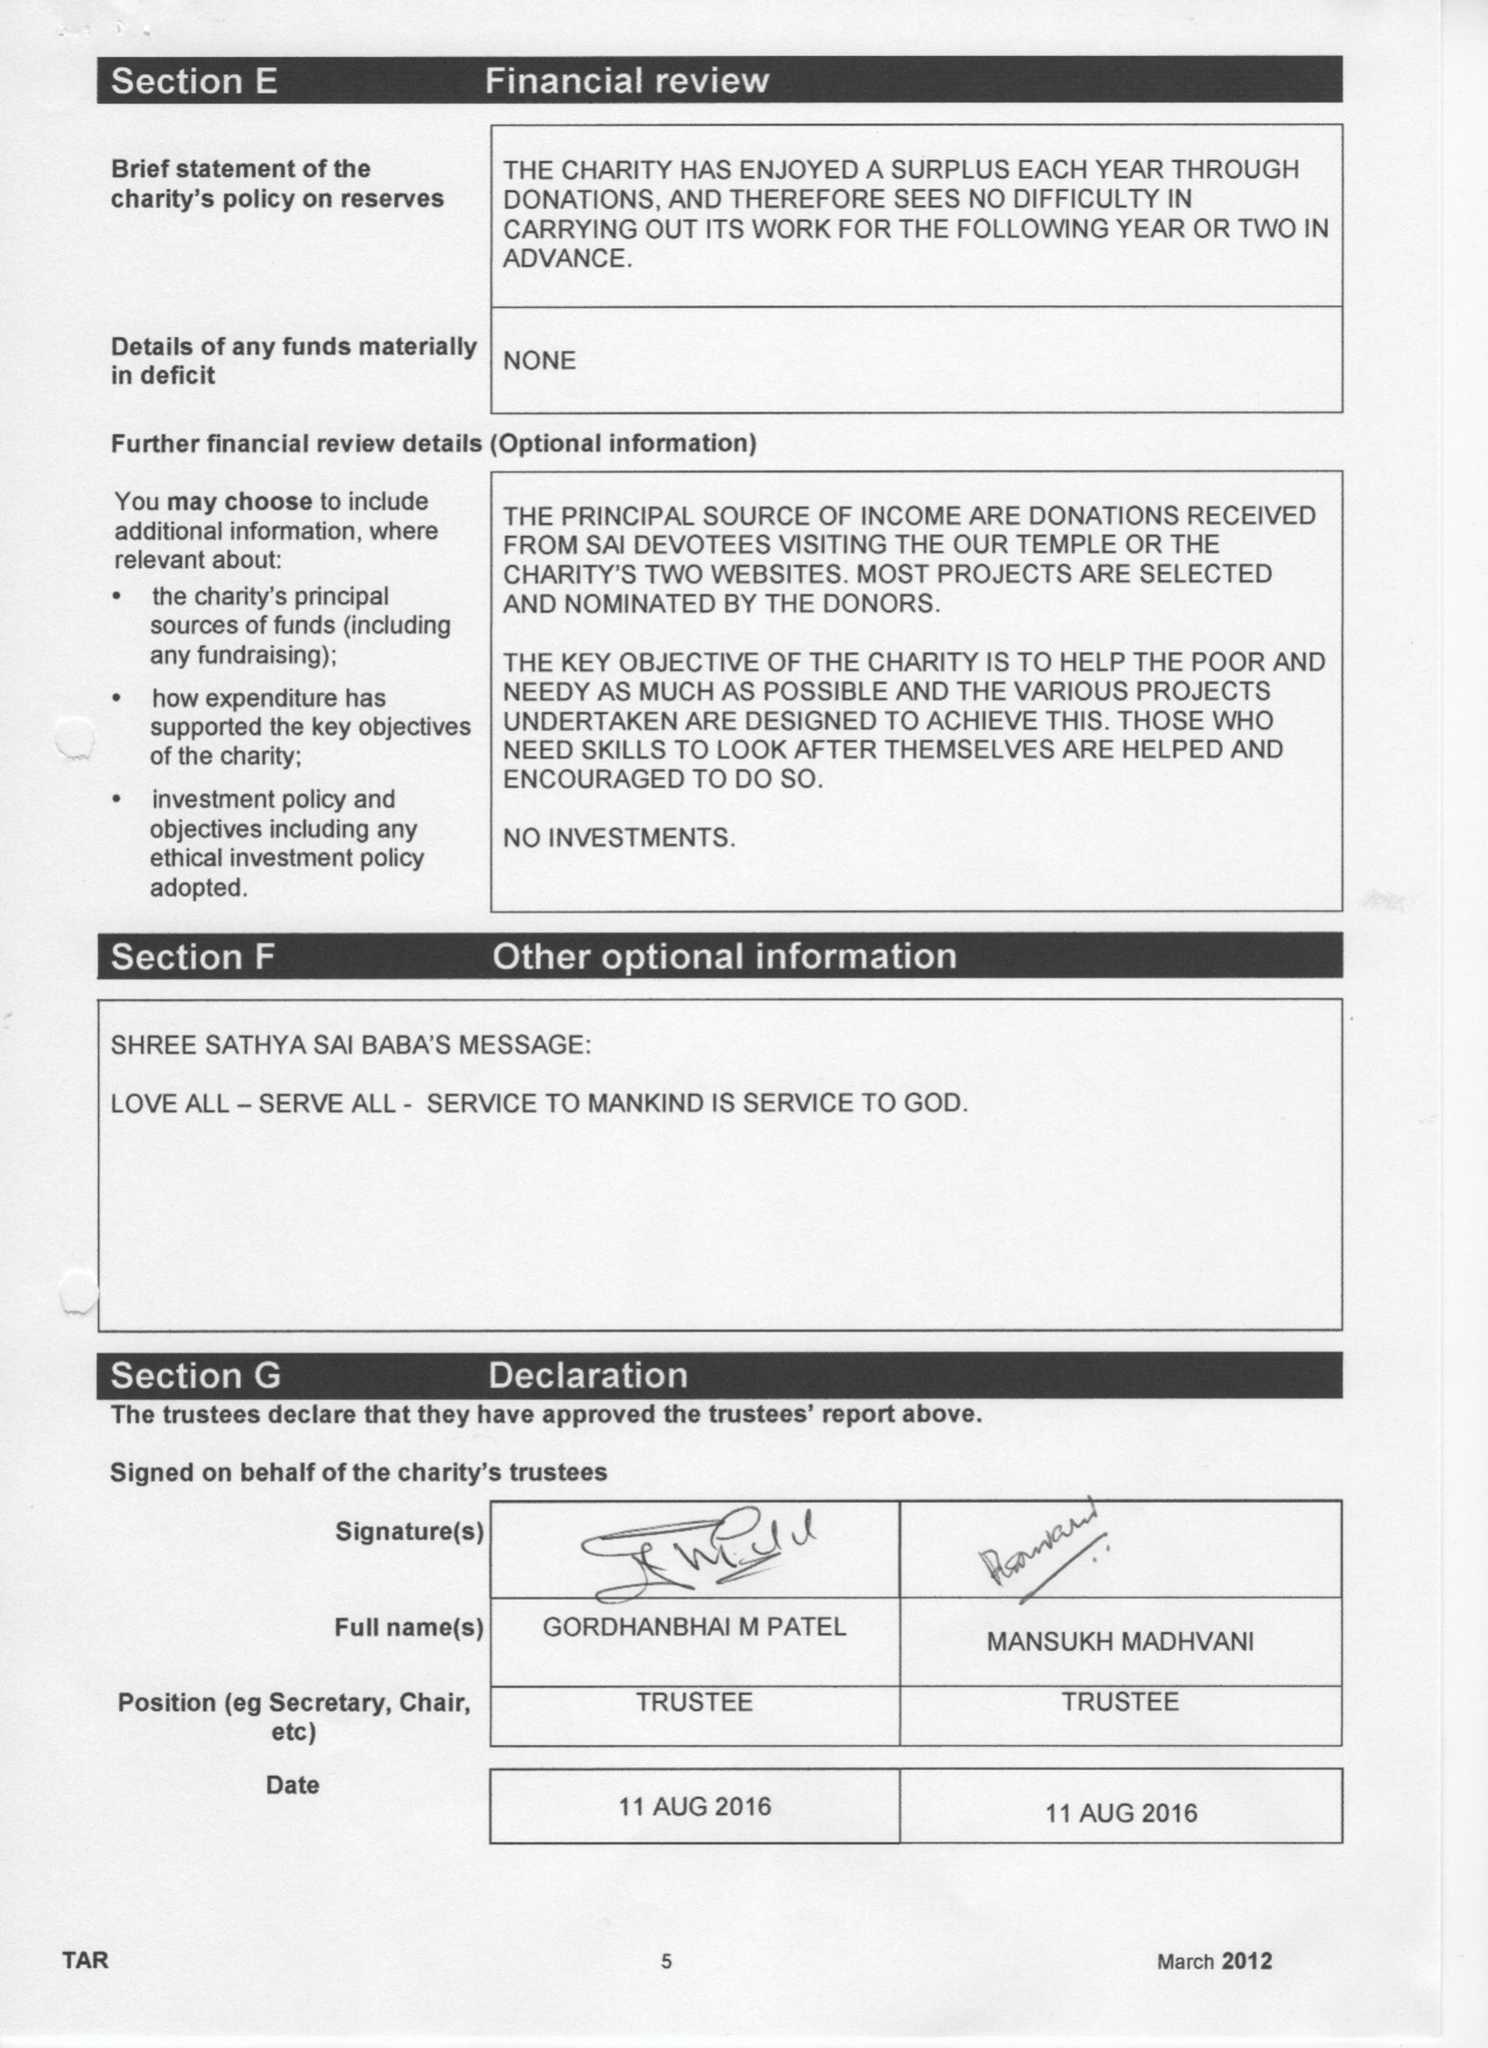What is the value for the charity_number?
Answer the question using a single word or phrase. 1123808 